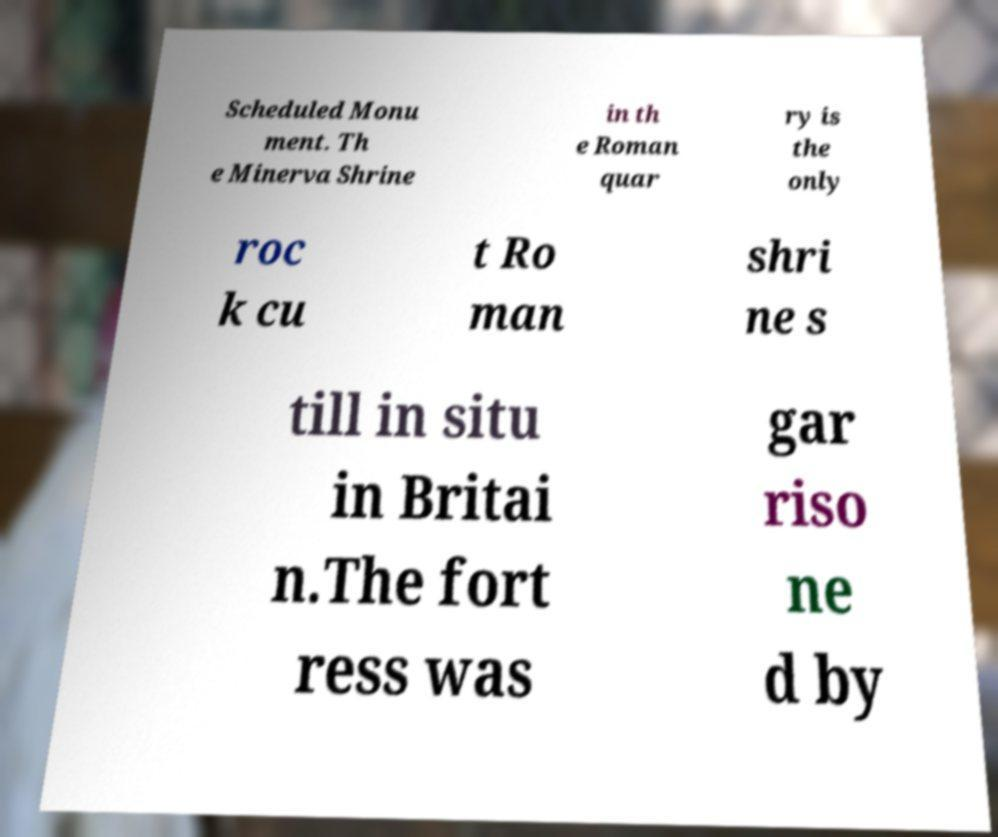Please read and relay the text visible in this image. What does it say? Scheduled Monu ment. Th e Minerva Shrine in th e Roman quar ry is the only roc k cu t Ro man shri ne s till in situ in Britai n.The fort ress was gar riso ne d by 